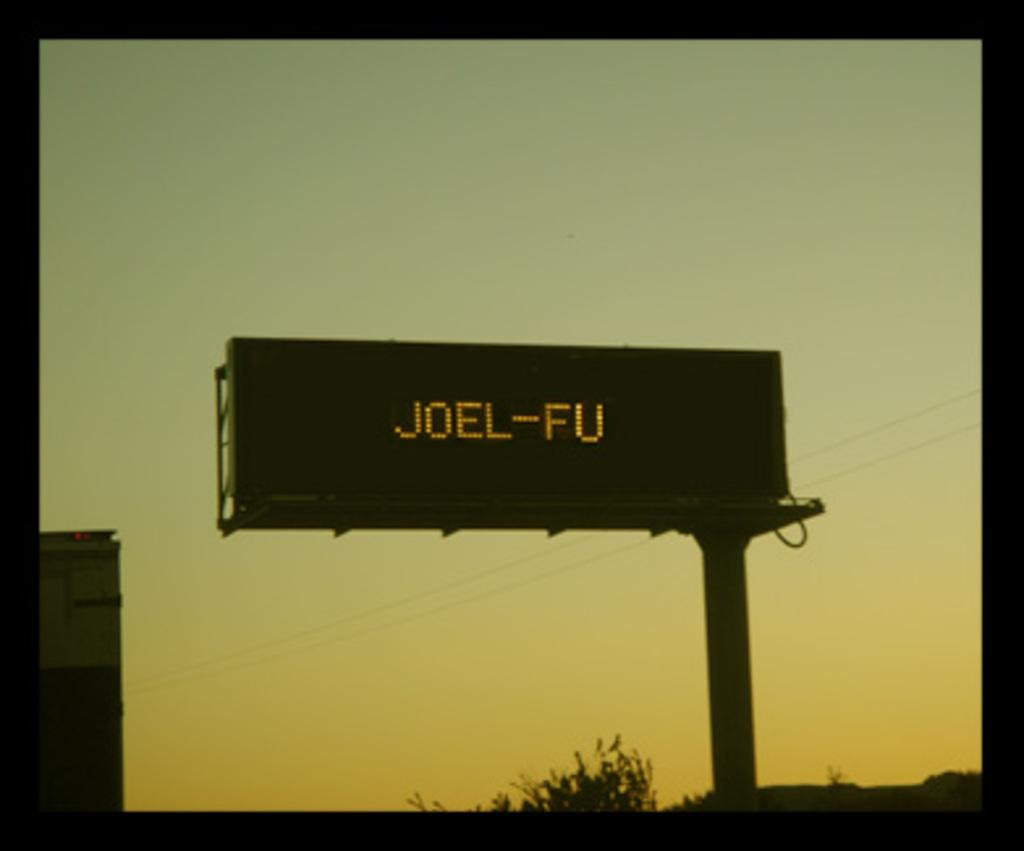Provide a one-sentence caption for the provided image. Sunrise or sunset background with a billboard that says Joel-FU. 